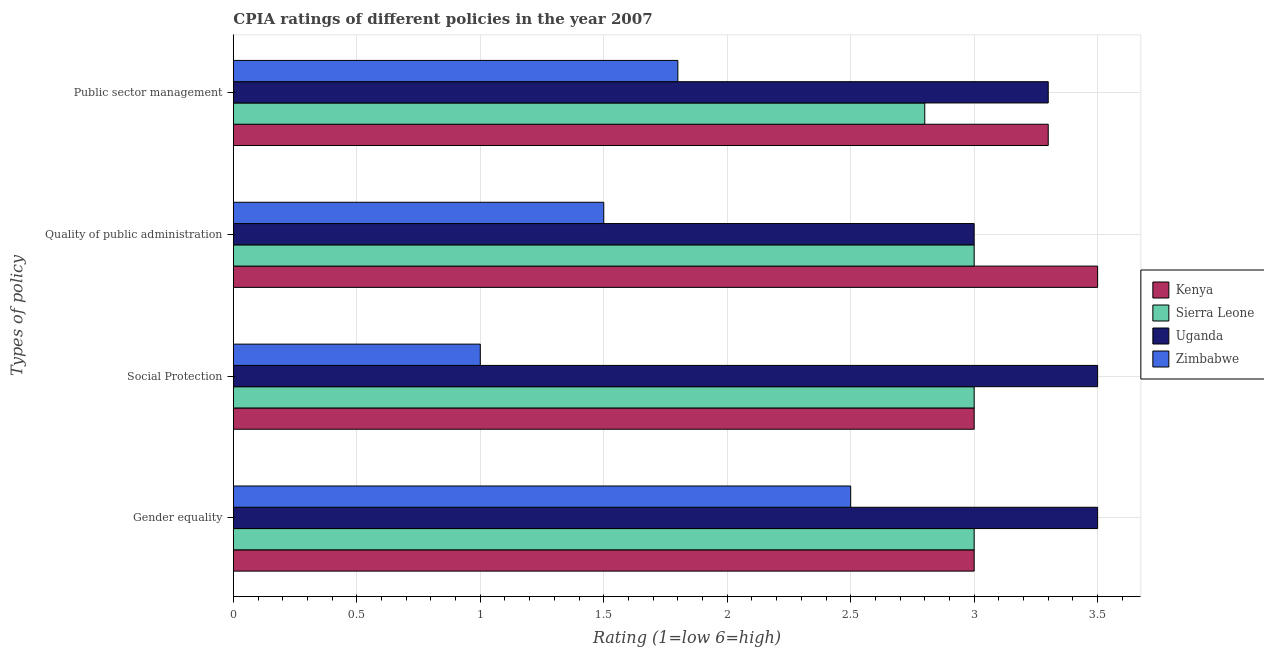Are the number of bars per tick equal to the number of legend labels?
Provide a short and direct response. Yes. How many bars are there on the 3rd tick from the top?
Your answer should be compact. 4. How many bars are there on the 2nd tick from the bottom?
Provide a succinct answer. 4. What is the label of the 2nd group of bars from the top?
Give a very brief answer. Quality of public administration. What is the cpia rating of quality of public administration in Sierra Leone?
Offer a terse response. 3. Across all countries, what is the minimum cpia rating of social protection?
Provide a succinct answer. 1. In which country was the cpia rating of gender equality maximum?
Provide a succinct answer. Uganda. In which country was the cpia rating of quality of public administration minimum?
Offer a very short reply. Zimbabwe. What is the total cpia rating of social protection in the graph?
Keep it short and to the point. 10.5. What is the difference between the cpia rating of quality of public administration in Kenya and that in Sierra Leone?
Provide a succinct answer. 0.5. What is the average cpia rating of quality of public administration per country?
Make the answer very short. 2.75. In how many countries, is the cpia rating of quality of public administration greater than 1.9 ?
Your answer should be very brief. 3. What is the ratio of the cpia rating of gender equality in Kenya to that in Sierra Leone?
Provide a succinct answer. 1. Is the cpia rating of public sector management in Uganda less than that in Kenya?
Offer a terse response. No. Is the difference between the cpia rating of social protection in Zimbabwe and Sierra Leone greater than the difference between the cpia rating of gender equality in Zimbabwe and Sierra Leone?
Your answer should be very brief. No. Is the sum of the cpia rating of quality of public administration in Uganda and Sierra Leone greater than the maximum cpia rating of social protection across all countries?
Offer a terse response. Yes. What does the 3rd bar from the top in Social Protection represents?
Provide a short and direct response. Sierra Leone. What does the 3rd bar from the bottom in Gender equality represents?
Your answer should be very brief. Uganda. Are the values on the major ticks of X-axis written in scientific E-notation?
Your answer should be very brief. No. Does the graph contain any zero values?
Your answer should be very brief. No. How many legend labels are there?
Your response must be concise. 4. What is the title of the graph?
Your answer should be very brief. CPIA ratings of different policies in the year 2007. What is the label or title of the X-axis?
Your response must be concise. Rating (1=low 6=high). What is the label or title of the Y-axis?
Make the answer very short. Types of policy. What is the Rating (1=low 6=high) of Kenya in Gender equality?
Give a very brief answer. 3. What is the Rating (1=low 6=high) of Sierra Leone in Gender equality?
Provide a short and direct response. 3. What is the Rating (1=low 6=high) of Uganda in Gender equality?
Your answer should be very brief. 3.5. What is the Rating (1=low 6=high) of Zimbabwe in Gender equality?
Give a very brief answer. 2.5. What is the Rating (1=low 6=high) in Sierra Leone in Social Protection?
Provide a succinct answer. 3. What is the Rating (1=low 6=high) of Kenya in Quality of public administration?
Make the answer very short. 3.5. What is the Rating (1=low 6=high) in Zimbabwe in Quality of public administration?
Offer a terse response. 1.5. What is the Rating (1=low 6=high) in Kenya in Public sector management?
Ensure brevity in your answer.  3.3. What is the Rating (1=low 6=high) of Sierra Leone in Public sector management?
Make the answer very short. 2.8. What is the Rating (1=low 6=high) of Uganda in Public sector management?
Your answer should be very brief. 3.3. Across all Types of policy, what is the maximum Rating (1=low 6=high) in Sierra Leone?
Offer a very short reply. 3. Across all Types of policy, what is the maximum Rating (1=low 6=high) of Uganda?
Offer a terse response. 3.5. Across all Types of policy, what is the minimum Rating (1=low 6=high) in Kenya?
Your answer should be very brief. 3. Across all Types of policy, what is the minimum Rating (1=low 6=high) of Sierra Leone?
Keep it short and to the point. 2.8. Across all Types of policy, what is the minimum Rating (1=low 6=high) in Uganda?
Your answer should be very brief. 3. What is the total Rating (1=low 6=high) of Sierra Leone in the graph?
Ensure brevity in your answer.  11.8. What is the total Rating (1=low 6=high) in Uganda in the graph?
Make the answer very short. 13.3. What is the difference between the Rating (1=low 6=high) in Sierra Leone in Gender equality and that in Social Protection?
Provide a short and direct response. 0. What is the difference between the Rating (1=low 6=high) of Uganda in Gender equality and that in Social Protection?
Ensure brevity in your answer.  0. What is the difference between the Rating (1=low 6=high) in Uganda in Gender equality and that in Quality of public administration?
Provide a short and direct response. 0.5. What is the difference between the Rating (1=low 6=high) in Kenya in Gender equality and that in Public sector management?
Give a very brief answer. -0.3. What is the difference between the Rating (1=low 6=high) in Sierra Leone in Gender equality and that in Public sector management?
Your answer should be compact. 0.2. What is the difference between the Rating (1=low 6=high) of Uganda in Gender equality and that in Public sector management?
Your answer should be compact. 0.2. What is the difference between the Rating (1=low 6=high) in Zimbabwe in Gender equality and that in Public sector management?
Your answer should be very brief. 0.7. What is the difference between the Rating (1=low 6=high) of Uganda in Social Protection and that in Quality of public administration?
Give a very brief answer. 0.5. What is the difference between the Rating (1=low 6=high) in Zimbabwe in Social Protection and that in Quality of public administration?
Provide a succinct answer. -0.5. What is the difference between the Rating (1=low 6=high) in Sierra Leone in Social Protection and that in Public sector management?
Your response must be concise. 0.2. What is the difference between the Rating (1=low 6=high) in Kenya in Quality of public administration and that in Public sector management?
Provide a short and direct response. 0.2. What is the difference between the Rating (1=low 6=high) of Sierra Leone in Quality of public administration and that in Public sector management?
Make the answer very short. 0.2. What is the difference between the Rating (1=low 6=high) of Kenya in Gender equality and the Rating (1=low 6=high) of Zimbabwe in Social Protection?
Your answer should be compact. 2. What is the difference between the Rating (1=low 6=high) of Sierra Leone in Gender equality and the Rating (1=low 6=high) of Uganda in Social Protection?
Your answer should be very brief. -0.5. What is the difference between the Rating (1=low 6=high) in Kenya in Gender equality and the Rating (1=low 6=high) in Uganda in Quality of public administration?
Give a very brief answer. 0. What is the difference between the Rating (1=low 6=high) in Kenya in Gender equality and the Rating (1=low 6=high) in Zimbabwe in Quality of public administration?
Offer a very short reply. 1.5. What is the difference between the Rating (1=low 6=high) in Sierra Leone in Gender equality and the Rating (1=low 6=high) in Uganda in Quality of public administration?
Ensure brevity in your answer.  0. What is the difference between the Rating (1=low 6=high) in Uganda in Gender equality and the Rating (1=low 6=high) in Zimbabwe in Quality of public administration?
Your response must be concise. 2. What is the difference between the Rating (1=low 6=high) of Kenya in Gender equality and the Rating (1=low 6=high) of Uganda in Public sector management?
Provide a short and direct response. -0.3. What is the difference between the Rating (1=low 6=high) of Kenya in Social Protection and the Rating (1=low 6=high) of Sierra Leone in Quality of public administration?
Give a very brief answer. 0. What is the difference between the Rating (1=low 6=high) of Kenya in Social Protection and the Rating (1=low 6=high) of Uganda in Quality of public administration?
Offer a very short reply. 0. What is the difference between the Rating (1=low 6=high) in Sierra Leone in Social Protection and the Rating (1=low 6=high) in Zimbabwe in Quality of public administration?
Provide a short and direct response. 1.5. What is the difference between the Rating (1=low 6=high) of Uganda in Social Protection and the Rating (1=low 6=high) of Zimbabwe in Quality of public administration?
Provide a succinct answer. 2. What is the difference between the Rating (1=low 6=high) in Kenya in Social Protection and the Rating (1=low 6=high) in Sierra Leone in Public sector management?
Your response must be concise. 0.2. What is the difference between the Rating (1=low 6=high) in Kenya in Social Protection and the Rating (1=low 6=high) in Uganda in Public sector management?
Provide a short and direct response. -0.3. What is the difference between the Rating (1=low 6=high) of Kenya in Social Protection and the Rating (1=low 6=high) of Zimbabwe in Public sector management?
Keep it short and to the point. 1.2. What is the difference between the Rating (1=low 6=high) of Sierra Leone in Social Protection and the Rating (1=low 6=high) of Zimbabwe in Public sector management?
Give a very brief answer. 1.2. What is the difference between the Rating (1=low 6=high) in Uganda in Social Protection and the Rating (1=low 6=high) in Zimbabwe in Public sector management?
Your answer should be very brief. 1.7. What is the difference between the Rating (1=low 6=high) of Kenya in Quality of public administration and the Rating (1=low 6=high) of Zimbabwe in Public sector management?
Provide a succinct answer. 1.7. What is the difference between the Rating (1=low 6=high) of Sierra Leone in Quality of public administration and the Rating (1=low 6=high) of Zimbabwe in Public sector management?
Offer a very short reply. 1.2. What is the average Rating (1=low 6=high) of Kenya per Types of policy?
Provide a short and direct response. 3.2. What is the average Rating (1=low 6=high) in Sierra Leone per Types of policy?
Provide a short and direct response. 2.95. What is the average Rating (1=low 6=high) in Uganda per Types of policy?
Your response must be concise. 3.33. What is the average Rating (1=low 6=high) of Zimbabwe per Types of policy?
Give a very brief answer. 1.7. What is the difference between the Rating (1=low 6=high) of Kenya and Rating (1=low 6=high) of Zimbabwe in Gender equality?
Provide a succinct answer. 0.5. What is the difference between the Rating (1=low 6=high) in Sierra Leone and Rating (1=low 6=high) in Uganda in Gender equality?
Provide a short and direct response. -0.5. What is the difference between the Rating (1=low 6=high) of Sierra Leone and Rating (1=low 6=high) of Zimbabwe in Gender equality?
Make the answer very short. 0.5. What is the difference between the Rating (1=low 6=high) of Kenya and Rating (1=low 6=high) of Uganda in Social Protection?
Keep it short and to the point. -0.5. What is the difference between the Rating (1=low 6=high) of Kenya and Rating (1=low 6=high) of Zimbabwe in Social Protection?
Keep it short and to the point. 2. What is the difference between the Rating (1=low 6=high) in Sierra Leone and Rating (1=low 6=high) in Uganda in Social Protection?
Provide a succinct answer. -0.5. What is the difference between the Rating (1=low 6=high) in Sierra Leone and Rating (1=low 6=high) in Zimbabwe in Social Protection?
Provide a short and direct response. 2. What is the difference between the Rating (1=low 6=high) of Uganda and Rating (1=low 6=high) of Zimbabwe in Social Protection?
Provide a succinct answer. 2.5. What is the difference between the Rating (1=low 6=high) of Kenya and Rating (1=low 6=high) of Uganda in Quality of public administration?
Make the answer very short. 0.5. What is the difference between the Rating (1=low 6=high) of Kenya and Rating (1=low 6=high) of Zimbabwe in Quality of public administration?
Provide a succinct answer. 2. What is the difference between the Rating (1=low 6=high) of Sierra Leone and Rating (1=low 6=high) of Uganda in Quality of public administration?
Provide a short and direct response. 0. What is the difference between the Rating (1=low 6=high) in Sierra Leone and Rating (1=low 6=high) in Zimbabwe in Quality of public administration?
Provide a short and direct response. 1.5. What is the difference between the Rating (1=low 6=high) in Uganda and Rating (1=low 6=high) in Zimbabwe in Quality of public administration?
Offer a very short reply. 1.5. What is the difference between the Rating (1=low 6=high) of Kenya and Rating (1=low 6=high) of Uganda in Public sector management?
Your answer should be compact. 0. What is the difference between the Rating (1=low 6=high) in Sierra Leone and Rating (1=low 6=high) in Uganda in Public sector management?
Ensure brevity in your answer.  -0.5. What is the difference between the Rating (1=low 6=high) of Sierra Leone and Rating (1=low 6=high) of Zimbabwe in Public sector management?
Your answer should be compact. 1. What is the difference between the Rating (1=low 6=high) of Uganda and Rating (1=low 6=high) of Zimbabwe in Public sector management?
Offer a very short reply. 1.5. What is the ratio of the Rating (1=low 6=high) of Zimbabwe in Gender equality to that in Social Protection?
Provide a succinct answer. 2.5. What is the ratio of the Rating (1=low 6=high) in Sierra Leone in Gender equality to that in Public sector management?
Provide a succinct answer. 1.07. What is the ratio of the Rating (1=low 6=high) in Uganda in Gender equality to that in Public sector management?
Your response must be concise. 1.06. What is the ratio of the Rating (1=low 6=high) of Zimbabwe in Gender equality to that in Public sector management?
Your response must be concise. 1.39. What is the ratio of the Rating (1=low 6=high) of Uganda in Social Protection to that in Quality of public administration?
Make the answer very short. 1.17. What is the ratio of the Rating (1=low 6=high) of Zimbabwe in Social Protection to that in Quality of public administration?
Your response must be concise. 0.67. What is the ratio of the Rating (1=low 6=high) in Kenya in Social Protection to that in Public sector management?
Ensure brevity in your answer.  0.91. What is the ratio of the Rating (1=low 6=high) of Sierra Leone in Social Protection to that in Public sector management?
Your answer should be compact. 1.07. What is the ratio of the Rating (1=low 6=high) of Uganda in Social Protection to that in Public sector management?
Your answer should be compact. 1.06. What is the ratio of the Rating (1=low 6=high) in Zimbabwe in Social Protection to that in Public sector management?
Your response must be concise. 0.56. What is the ratio of the Rating (1=low 6=high) of Kenya in Quality of public administration to that in Public sector management?
Provide a succinct answer. 1.06. What is the ratio of the Rating (1=low 6=high) of Sierra Leone in Quality of public administration to that in Public sector management?
Give a very brief answer. 1.07. What is the difference between the highest and the second highest Rating (1=low 6=high) of Kenya?
Make the answer very short. 0.2. What is the difference between the highest and the second highest Rating (1=low 6=high) in Sierra Leone?
Ensure brevity in your answer.  0. What is the difference between the highest and the second highest Rating (1=low 6=high) in Zimbabwe?
Offer a terse response. 0.7. What is the difference between the highest and the lowest Rating (1=low 6=high) of Sierra Leone?
Provide a short and direct response. 0.2. 